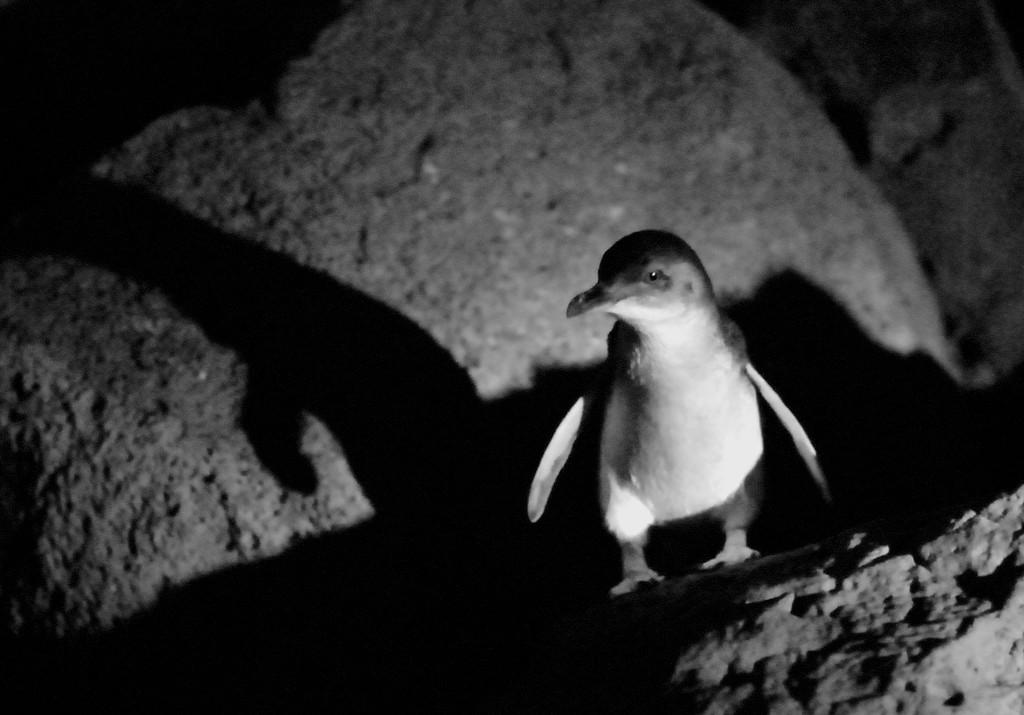What type of animal can be seen in the picture? There is a bird in the picture. What color scheme is used in the photography? The photography is in black and white. What type of head injury did the bird suffer in the picture? There is no indication of a head injury or any medical situation in the picture, as it simply features a bird. 